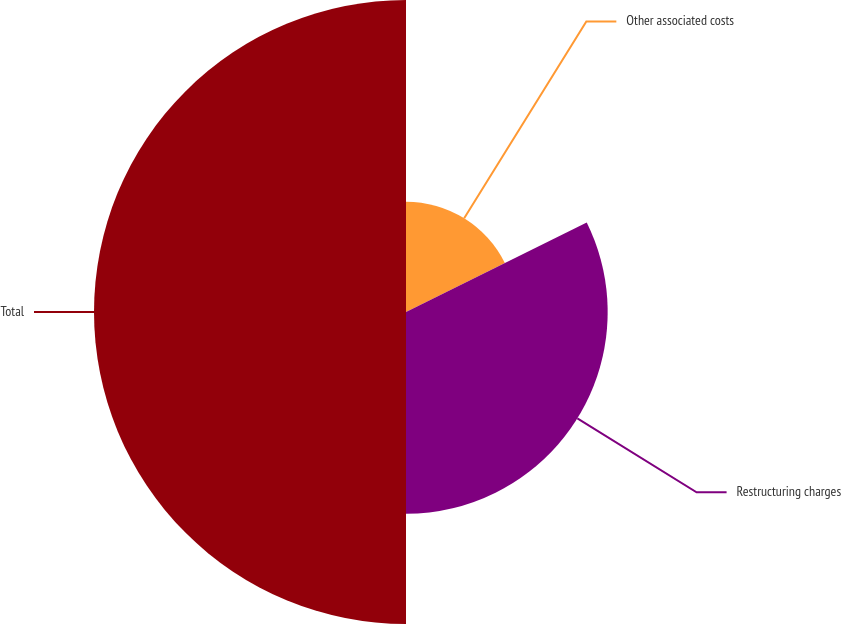Convert chart. <chart><loc_0><loc_0><loc_500><loc_500><pie_chart><fcel>Other associated costs<fcel>Restructuring charges<fcel>Total<nl><fcel>17.68%<fcel>32.32%<fcel>50.0%<nl></chart> 